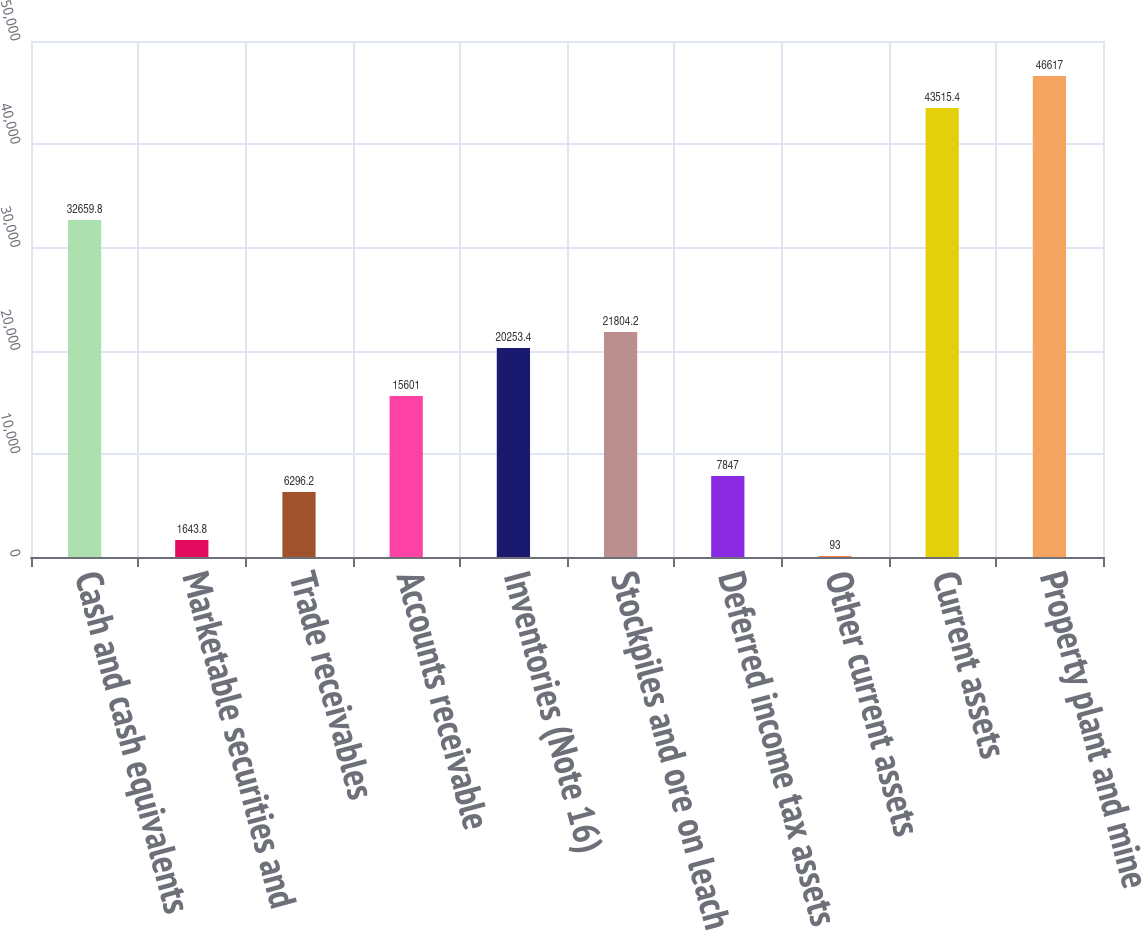Convert chart to OTSL. <chart><loc_0><loc_0><loc_500><loc_500><bar_chart><fcel>Cash and cash equivalents<fcel>Marketable securities and<fcel>Trade receivables<fcel>Accounts receivable<fcel>Inventories (Note 16)<fcel>Stockpiles and ore on leach<fcel>Deferred income tax assets<fcel>Other current assets<fcel>Current assets<fcel>Property plant and mine<nl><fcel>32659.8<fcel>1643.8<fcel>6296.2<fcel>15601<fcel>20253.4<fcel>21804.2<fcel>7847<fcel>93<fcel>43515.4<fcel>46617<nl></chart> 